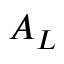<formula> <loc_0><loc_0><loc_500><loc_500>A _ { L }</formula> 